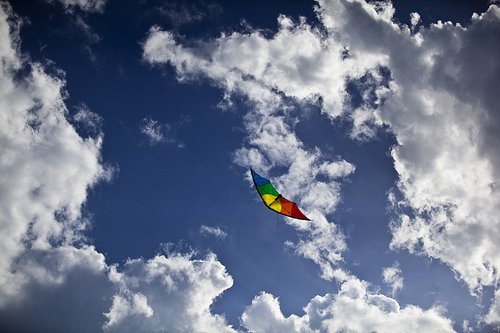<image>
Is the kite next to the cloud? Yes. The kite is positioned adjacent to the cloud, located nearby in the same general area. Where is the kite in relation to the sky? Is it to the right of the sky? No. The kite is not to the right of the sky. The horizontal positioning shows a different relationship. 